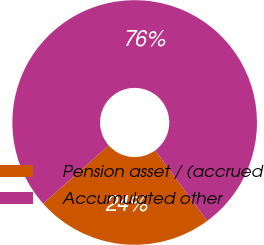Convert chart to OTSL. <chart><loc_0><loc_0><loc_500><loc_500><pie_chart><fcel>Pension asset / (accrued<fcel>Accumulated other<nl><fcel>23.57%<fcel>76.43%<nl></chart> 